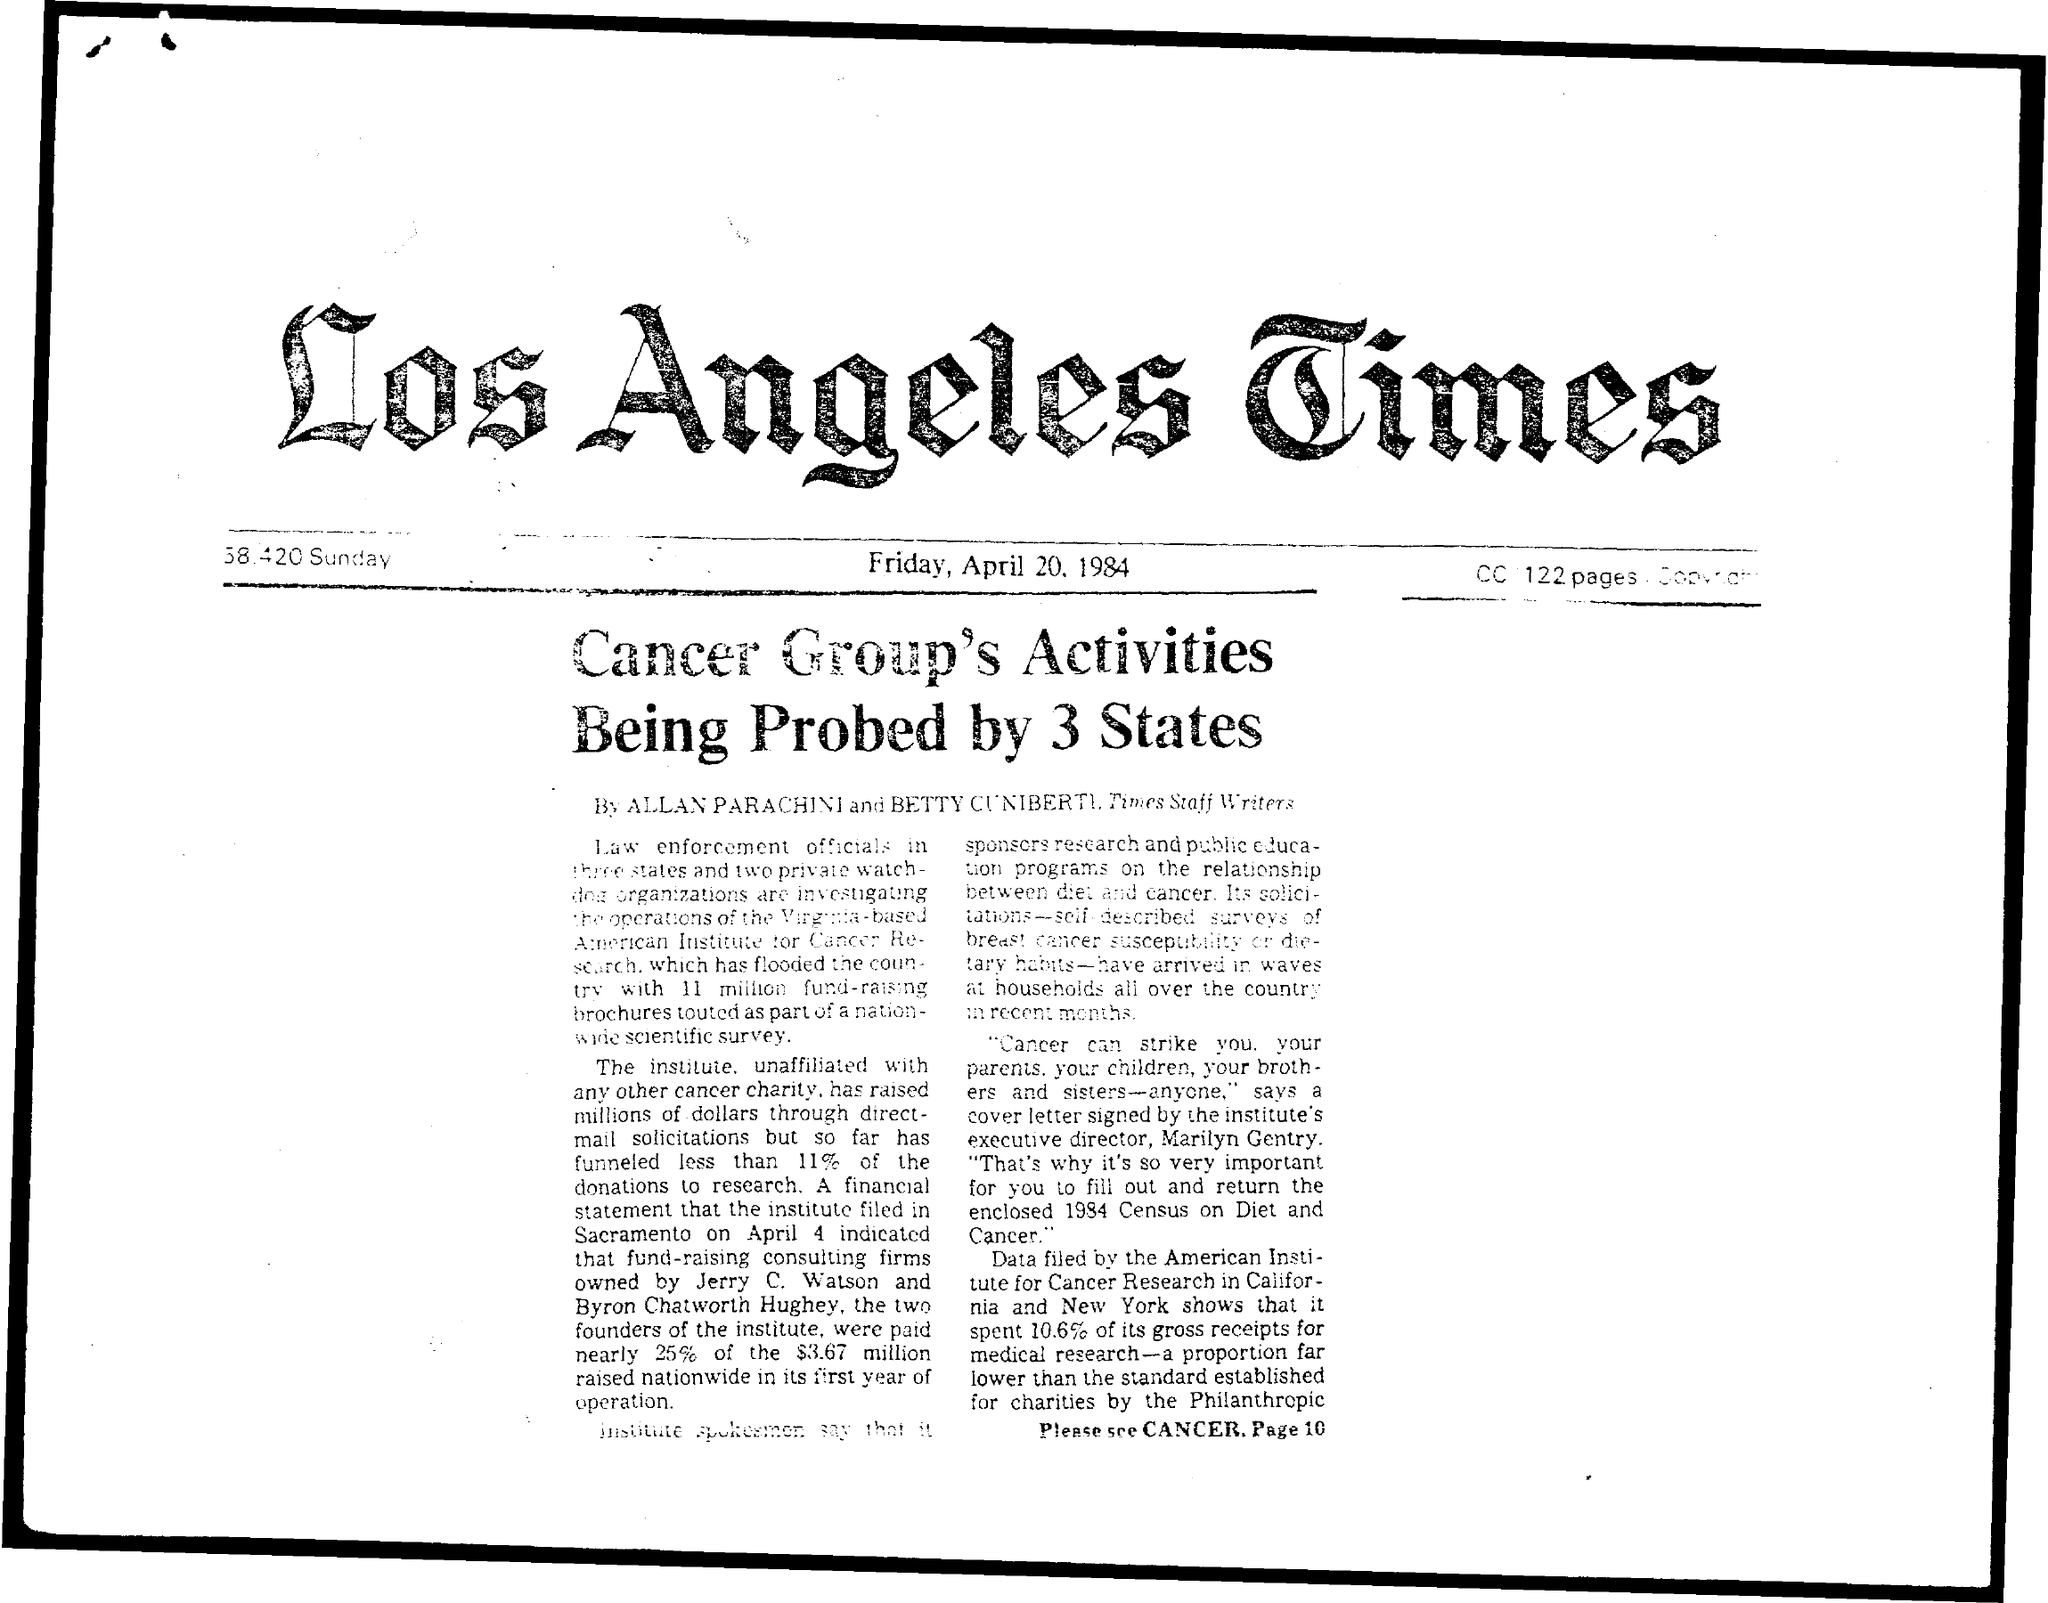Indicate a few pertinent items in this graphic. There are 122 pages mentioned in the CC. 